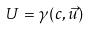<formula> <loc_0><loc_0><loc_500><loc_500>U = \gamma ( c , \vec { u } )</formula> 